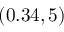<formula> <loc_0><loc_0><loc_500><loc_500>( 0 . 3 4 , 5 )</formula> 